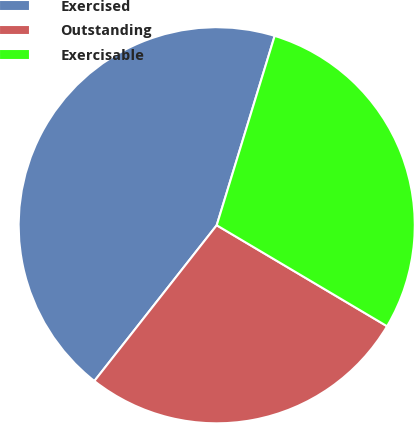Convert chart to OTSL. <chart><loc_0><loc_0><loc_500><loc_500><pie_chart><fcel>Exercised<fcel>Outstanding<fcel>Exercisable<nl><fcel>44.13%<fcel>27.08%<fcel>28.79%<nl></chart> 